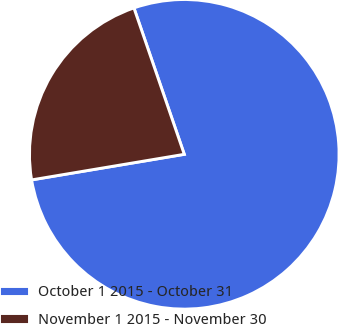Convert chart. <chart><loc_0><loc_0><loc_500><loc_500><pie_chart><fcel>October 1 2015 - October 31<fcel>November 1 2015 - November 30<nl><fcel>77.63%<fcel>22.37%<nl></chart> 